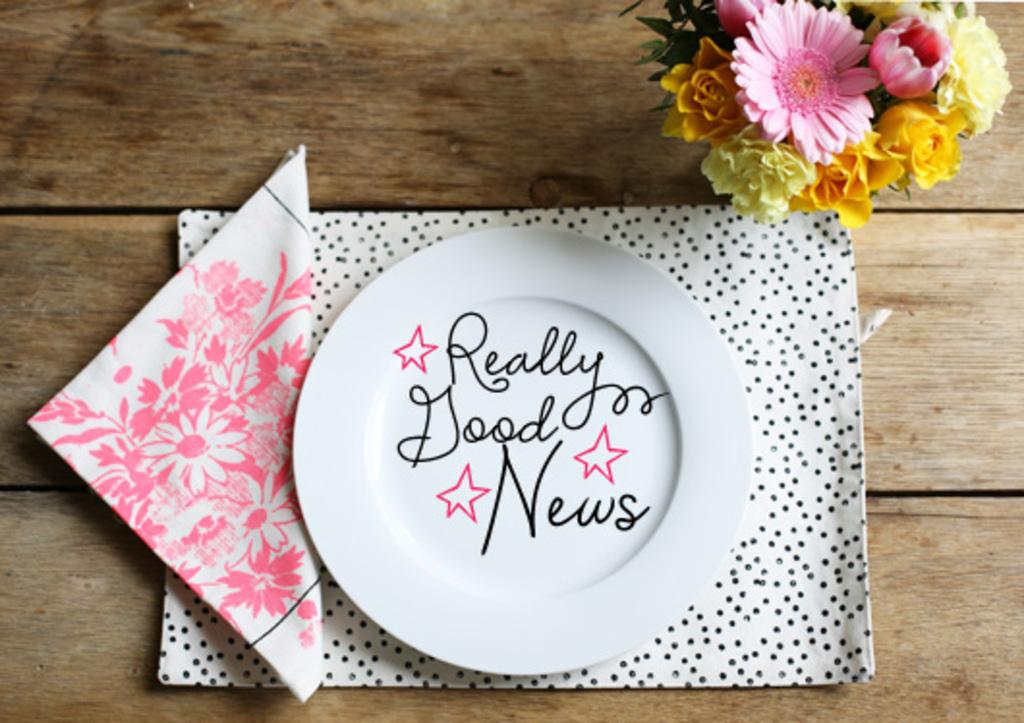<image>
Relay a brief, clear account of the picture shown. A plate is written with the words "really good news" 